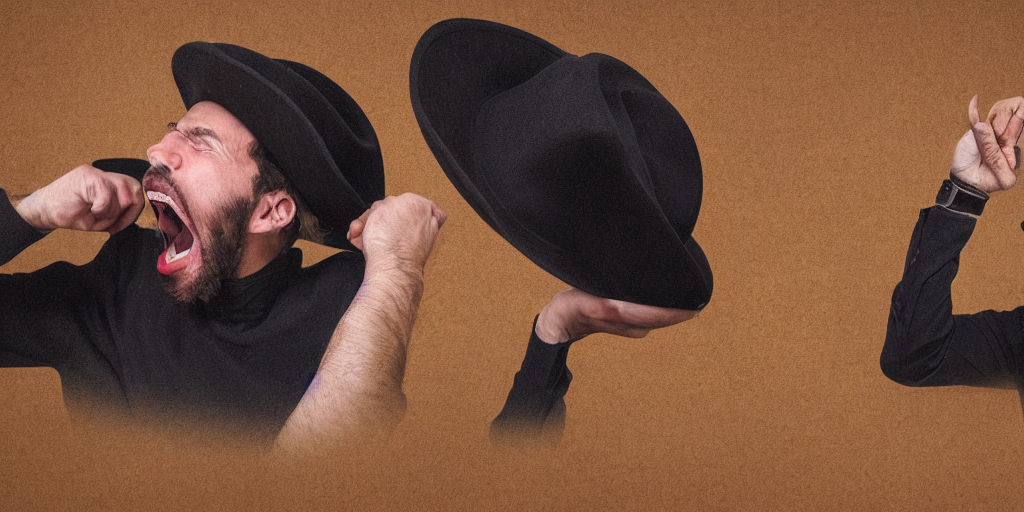What does this image represent? This image appears to artistically illustrate a concept of internal conflict or emotional expression. The use of two hats and the positioning suggests a single individual caught in two different moments or emotions, perhaps symbolizing a sudden outburst or change. 